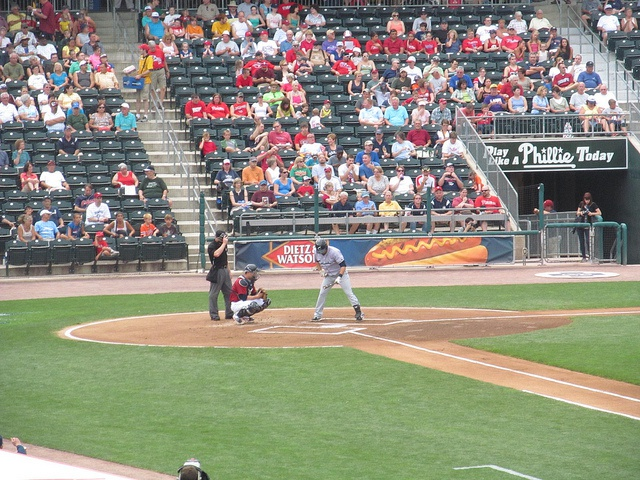Describe the objects in this image and their specific colors. I can see people in black, gray, lightgray, and darkgray tones, hot dog in black, tan, salmon, and gold tones, people in black, darkgray, lightgray, and gray tones, people in black, gray, darkgray, and lightpink tones, and people in black, gray, lavender, and darkgray tones in this image. 